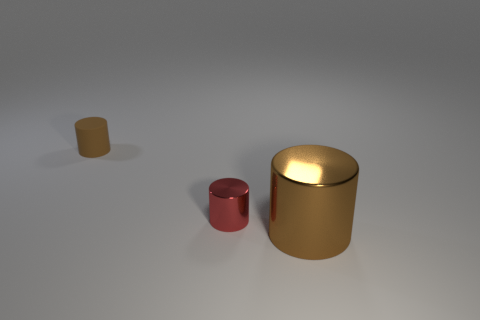Is the shape of the small thing that is behind the tiny red shiny cylinder the same as  the tiny metal thing?
Offer a terse response. Yes. What is the color of the small metal thing that is the same shape as the big brown shiny thing?
Make the answer very short. Red. Is there any other thing that is the same material as the large cylinder?
Your answer should be very brief. Yes. What size is the other brown thing that is the same shape as the big thing?
Offer a terse response. Small. What is the material of the thing that is both behind the brown metallic object and in front of the matte thing?
Ensure brevity in your answer.  Metal. Is the color of the rubber thing behind the tiny red object the same as the small shiny thing?
Offer a very short reply. No. Do the tiny shiny thing and the large cylinder on the right side of the tiny brown cylinder have the same color?
Give a very brief answer. No. There is a rubber cylinder; are there any red shiny objects to the right of it?
Make the answer very short. Yes. Is the material of the large brown cylinder the same as the small red cylinder?
Ensure brevity in your answer.  Yes. There is a thing that is the same size as the matte cylinder; what material is it?
Keep it short and to the point. Metal. 